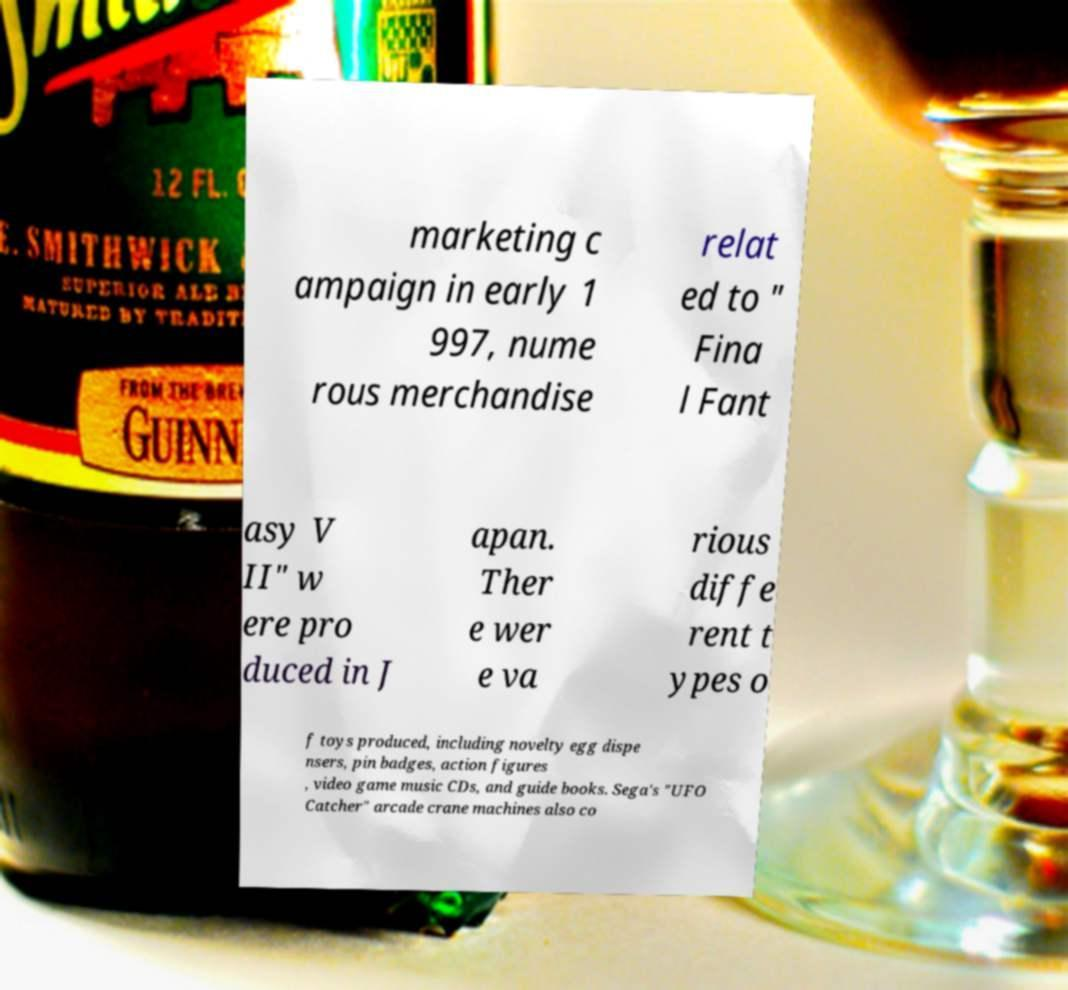Please identify and transcribe the text found in this image. marketing c ampaign in early 1 997, nume rous merchandise relat ed to " Fina l Fant asy V II" w ere pro duced in J apan. Ther e wer e va rious diffe rent t ypes o f toys produced, including novelty egg dispe nsers, pin badges, action figures , video game music CDs, and guide books. Sega's "UFO Catcher" arcade crane machines also co 